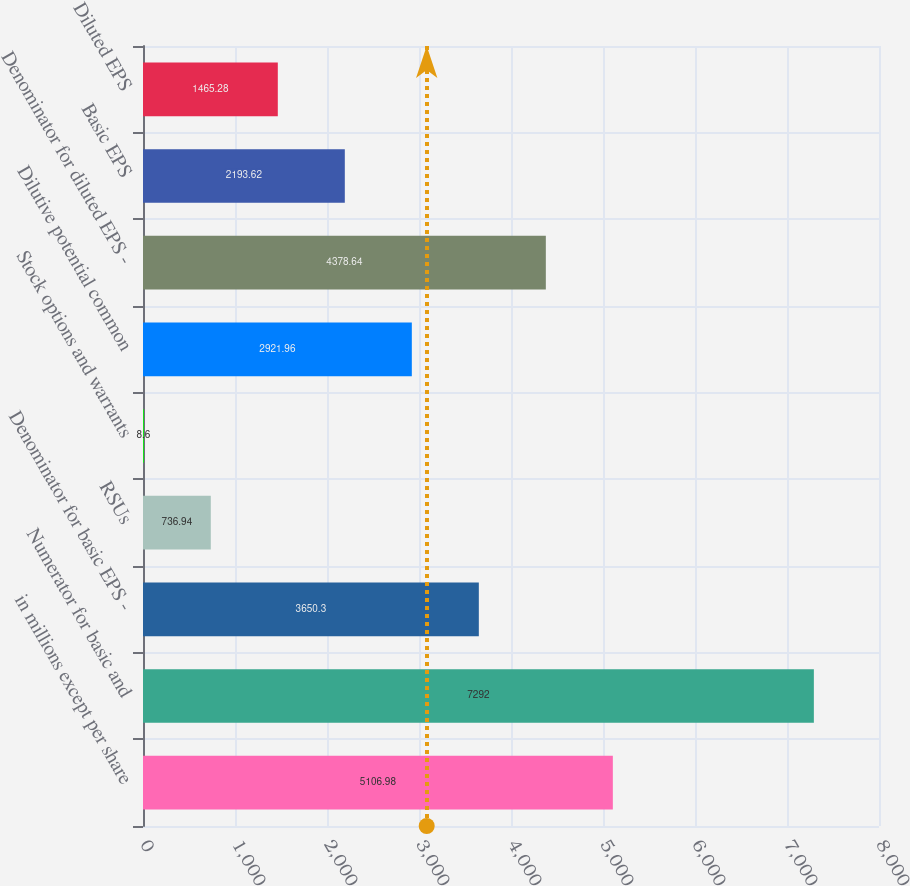Convert chart. <chart><loc_0><loc_0><loc_500><loc_500><bar_chart><fcel>in millions except per share<fcel>Numerator for basic and<fcel>Denominator for basic EPS -<fcel>RSUs<fcel>Stock options and warrants<fcel>Dilutive potential common<fcel>Denominator for diluted EPS -<fcel>Basic EPS<fcel>Diluted EPS<nl><fcel>5106.98<fcel>7292<fcel>3650.3<fcel>736.94<fcel>8.6<fcel>2921.96<fcel>4378.64<fcel>2193.62<fcel>1465.28<nl></chart> 